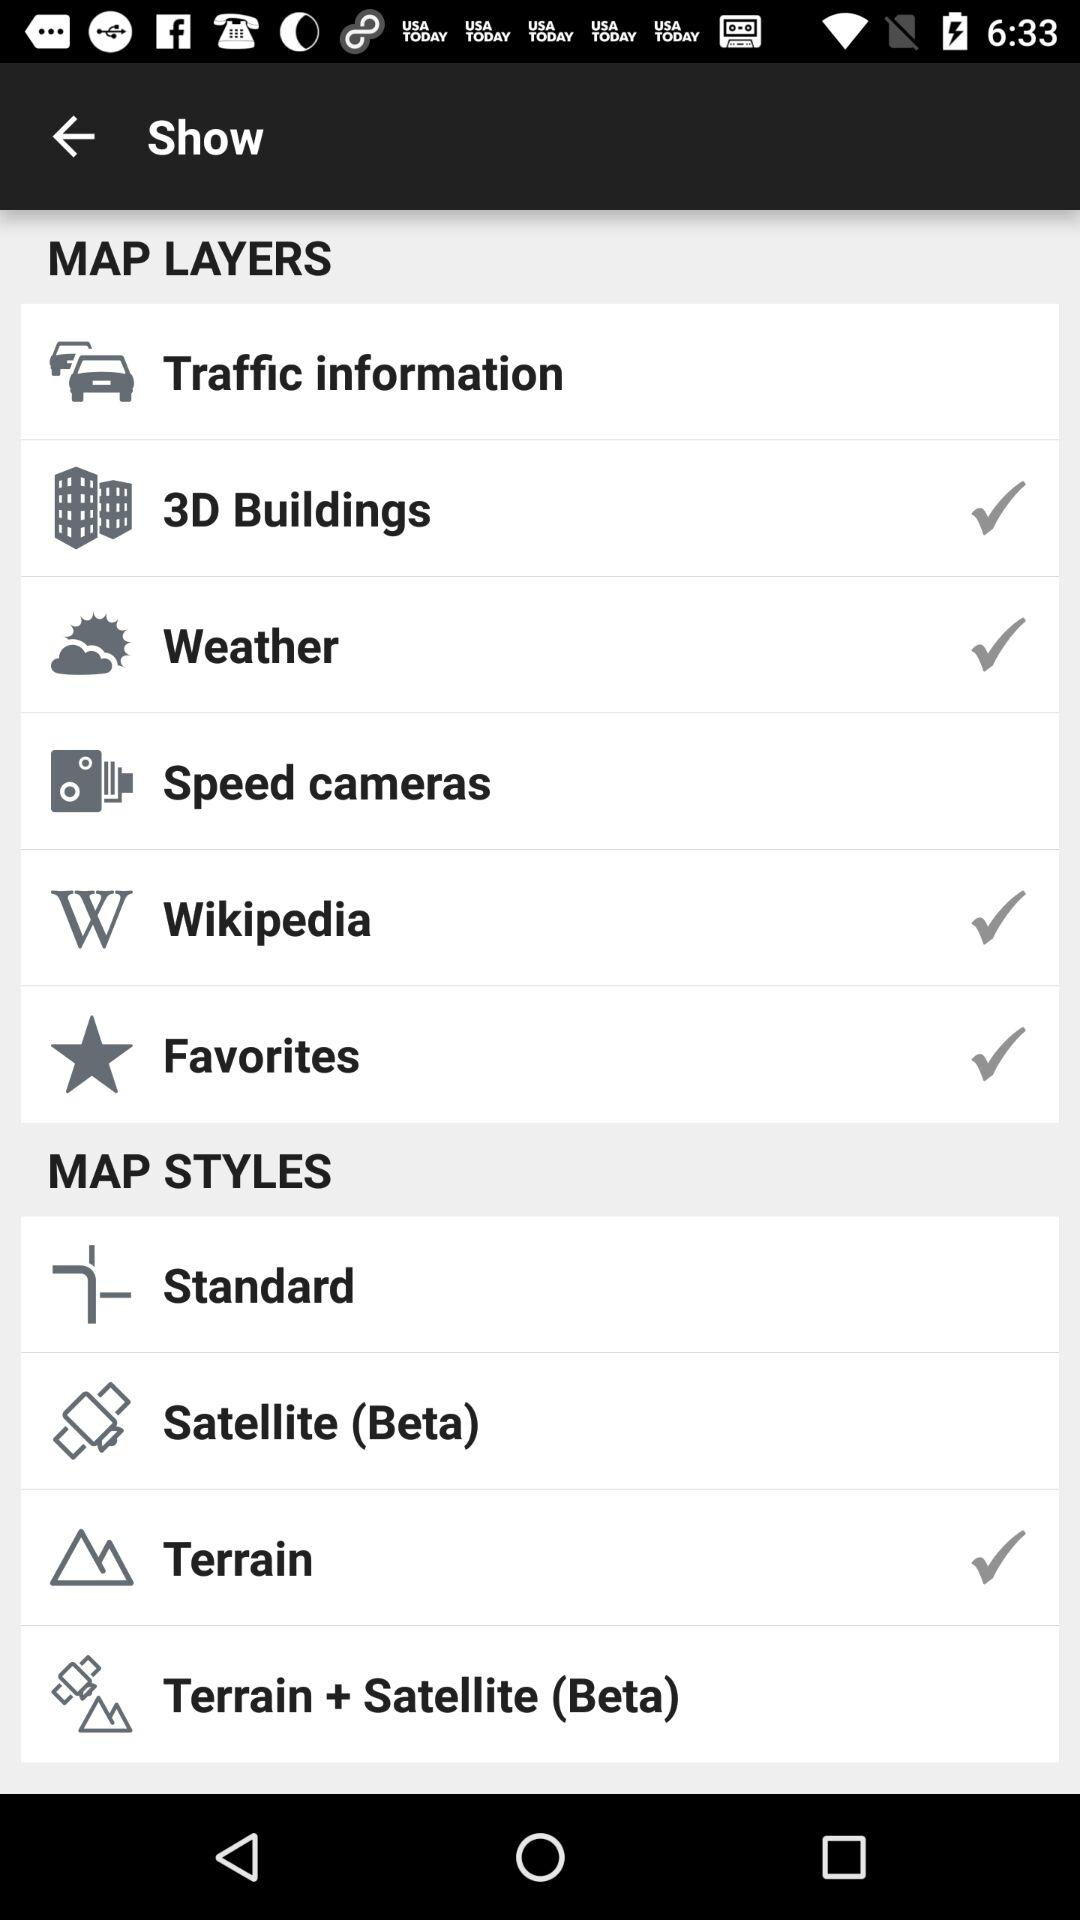What are the options in "Map styles"? The options are "Standard", "Satellite (Beta)", "Terrain" and "Terrain + Satellite (Beta)". 